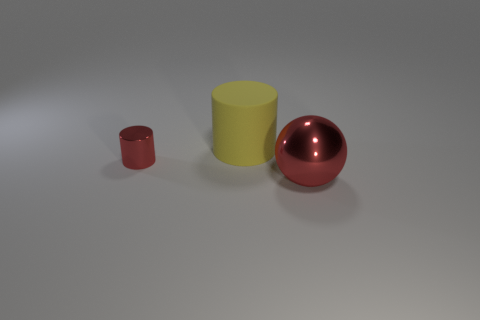Add 2 tiny red cylinders. How many objects exist? 5 Subtract all cylinders. How many objects are left? 1 Add 3 large rubber things. How many large rubber things exist? 4 Subtract 1 yellow cylinders. How many objects are left? 2 Subtract all matte cylinders. Subtract all big matte objects. How many objects are left? 1 Add 1 large things. How many large things are left? 3 